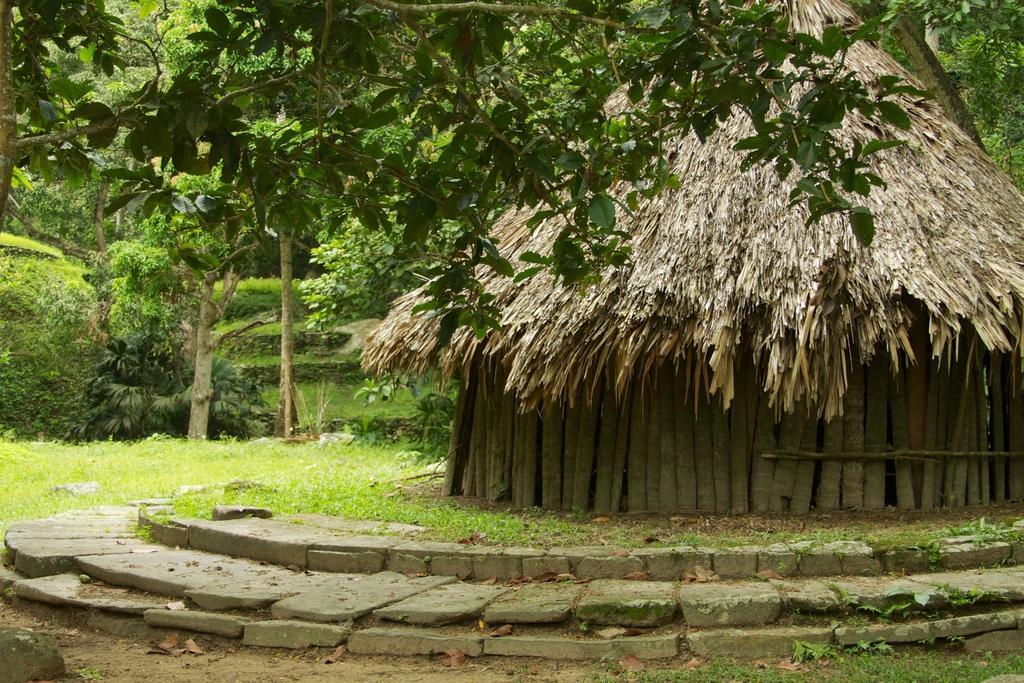How would you summarize this image in a sentence or two? As we can see in the image there is a hut, rocks, grass, plants and trees. 